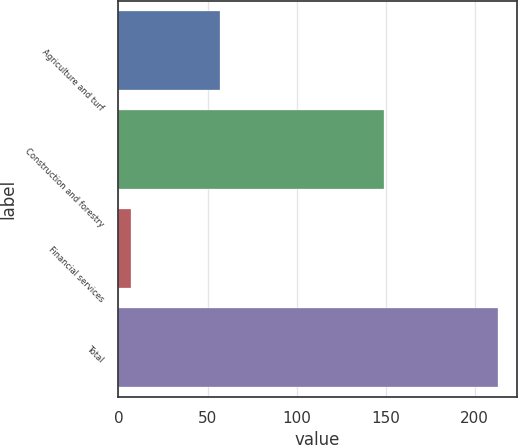Convert chart to OTSL. <chart><loc_0><loc_0><loc_500><loc_500><bar_chart><fcel>Agriculture and turf<fcel>Construction and forestry<fcel>Financial services<fcel>Total<nl><fcel>57<fcel>149<fcel>7<fcel>213<nl></chart> 